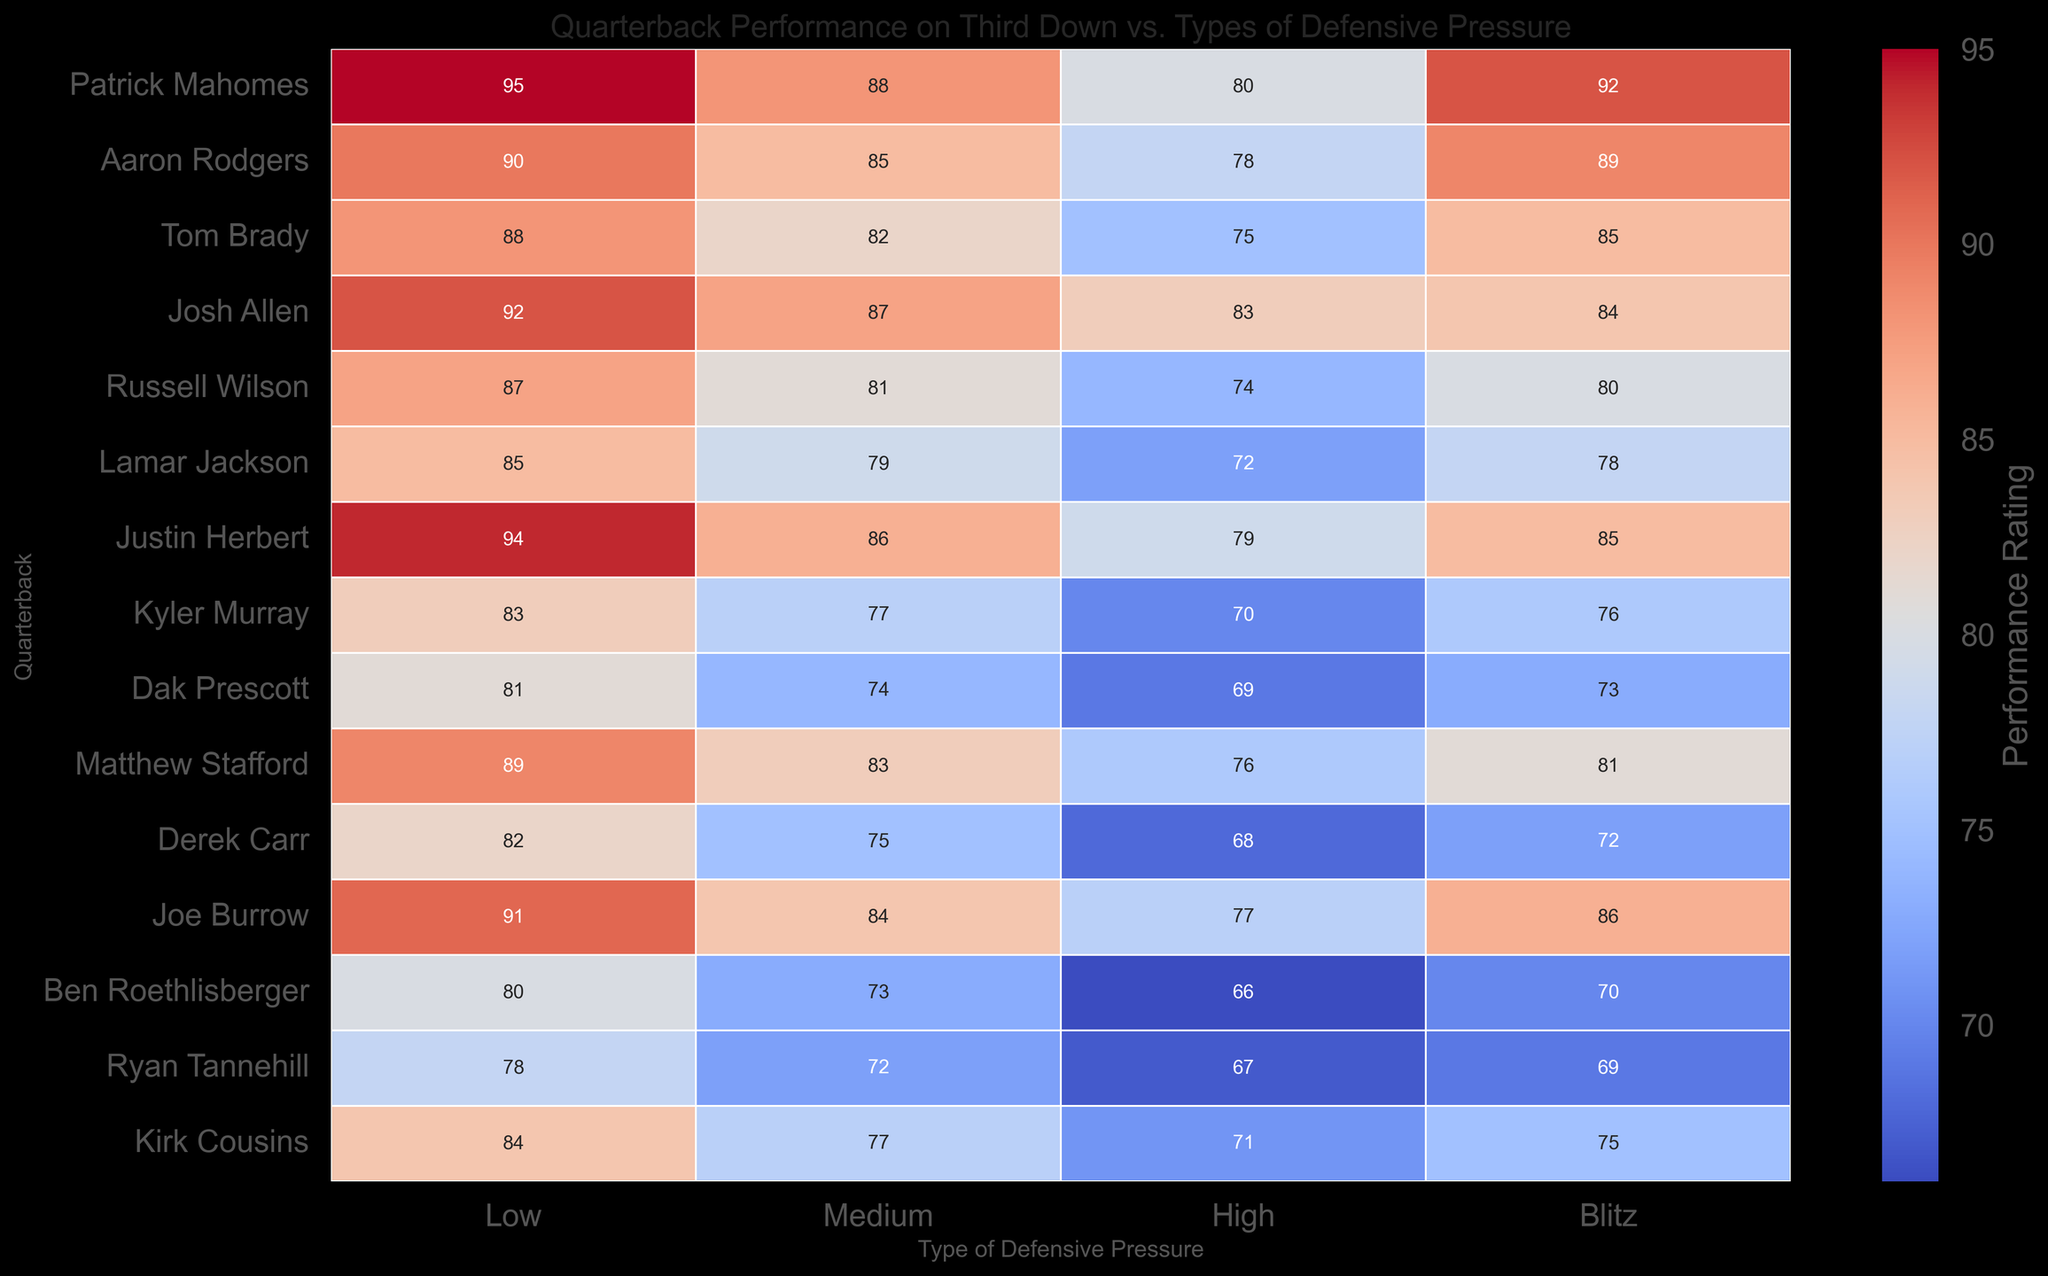Which quarterback has the highest performance rating under Low defensive pressure? Look at the column labeled "Low" in the heatmap. The highest value in this column corresponds to Patrick Mahomes with a rating of 95.
Answer: Patrick Mahomes Which quarterback performs better under Blitz pressure, Aaron Rodgers or Tom Brady? Look at the "Blitz" column and compare the values for Aaron Rodgers and Tom Brady. Aaron Rodgers has a rating of 89, while Tom Brady has a rating of 85.
Answer: Aaron Rodgers What is the sum of Patrick Mahomes' performance ratings across all defensive pressure types? Sum the values for Patrick Mahomes across all columns: Low (95) + Medium (88) + High (80) + Blitz (92). This total is 95 + 88 + 80 + 92 = 355.
Answer: 355 Which quarterback shows the smallest performance drop from Low to High defensive pressure? Calculate the performance drops for each quarterback and identify the smallest reduction. Patrick Mahomes drops from 95 to 80 (95-80 = 15), Aaron Rodgers from 90 to 78 (12), Tom Brady from 88 to 75 (13), etc. Josh Allen shows a drop from 92 to 83, which is the smallest reduction (92-83 = 9).
Answer: Josh Allen How do the performance ratings for Patrick Mahomes under Medium and Blitz pressures compare visually? Visually compare the colors corresponding to the ratings for Patrick Mahomes under Medium (88) and Blitz (92) pressures. The rating under Blitz is stronger (92) and thus visually represented by a more intense or warmer color.
Answer: Blitz pressure is better Which quarterback has the lowest performance rating under High defensive pressure? Look at the column labeled "High" and find the lowest value. Ben Roethlisberger has the lowest rating with 66.
Answer: Ben Roethlisberger How does the average performance of Tom Brady compare under Medium and High pressures? Average the ratings for Tom Brady under Medium (82) and High (75): (82 + 75) / 2 = 157 / 2 = 78.5.
Answer: 78.5 What is the difference in performance ratings between Patrick Mahomes and Russell Wilson under Blitz pressure? Subtract the Blitz rating of Russell Wilson (80) from that of Patrick Mahomes (92): 92 - 80 = 12.
Answer: 12 Which quarterback's performance under Low defensive pressure is closest to that of Matthew Stafford? Look at the "Low" column for Matthew Stafford's rating (89) and find the closest value. Aaron Rodgers has a rating of 90, which is the closest.
Answer: Aaron Rodgers Visualize the trend in performance ratings for Justin Herbert across all types of defensive pressures. What do you observe? Observe the columns corresponding to Justin Herbert. He has high ratings under Low (94), Medium (86), and then a decrease under High (79), followed by a slight increase under Blitz (85). This pattern shows a decrease under Medium to High pressure but a recovery under Blitz.
Answer: Decrease under High, recovery under Blitz 